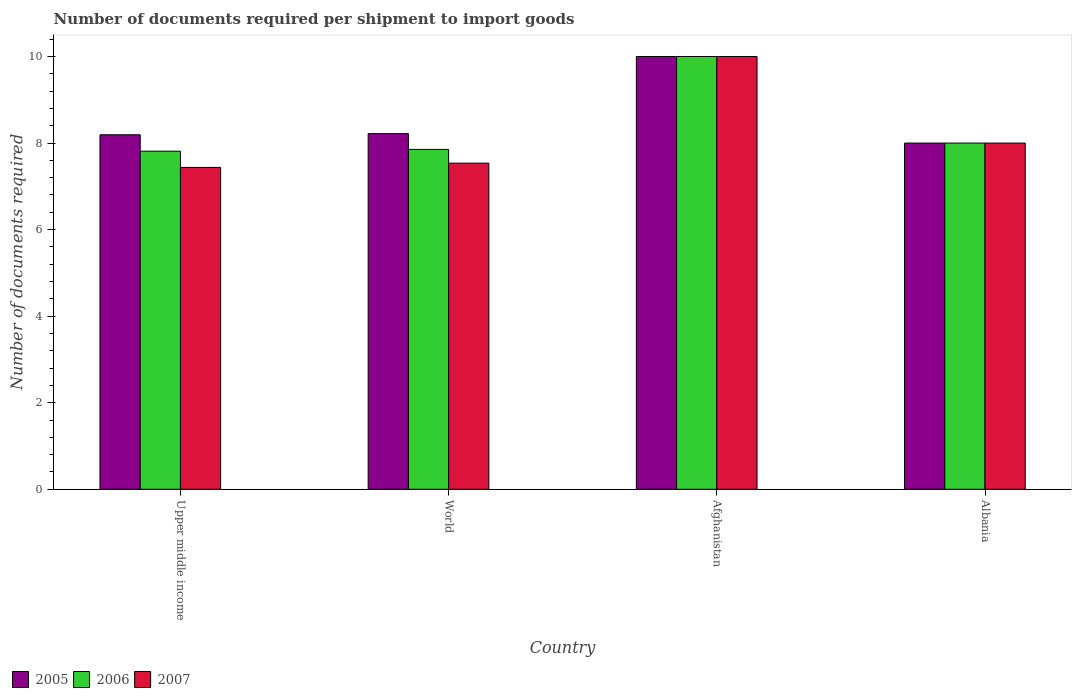How many groups of bars are there?
Your answer should be compact. 4. How many bars are there on the 4th tick from the left?
Make the answer very short. 3. What is the label of the 2nd group of bars from the left?
Your response must be concise. World. In how many cases, is the number of bars for a given country not equal to the number of legend labels?
Ensure brevity in your answer.  0. What is the number of documents required per shipment to import goods in 2007 in Afghanistan?
Give a very brief answer. 10. Across all countries, what is the maximum number of documents required per shipment to import goods in 2006?
Provide a succinct answer. 10. Across all countries, what is the minimum number of documents required per shipment to import goods in 2007?
Offer a very short reply. 7.44. In which country was the number of documents required per shipment to import goods in 2007 maximum?
Keep it short and to the point. Afghanistan. In which country was the number of documents required per shipment to import goods in 2006 minimum?
Provide a short and direct response. Upper middle income. What is the total number of documents required per shipment to import goods in 2007 in the graph?
Provide a succinct answer. 32.97. What is the difference between the number of documents required per shipment to import goods in 2006 in Afghanistan and that in World?
Keep it short and to the point. 2.15. What is the difference between the number of documents required per shipment to import goods in 2005 in World and the number of documents required per shipment to import goods in 2007 in Afghanistan?
Your response must be concise. -1.78. What is the average number of documents required per shipment to import goods in 2006 per country?
Keep it short and to the point. 8.42. What is the difference between the number of documents required per shipment to import goods of/in 2006 and number of documents required per shipment to import goods of/in 2005 in World?
Provide a succinct answer. -0.36. In how many countries, is the number of documents required per shipment to import goods in 2005 greater than 5.6?
Your answer should be compact. 4. Is the number of documents required per shipment to import goods in 2005 in Albania less than that in Upper middle income?
Provide a succinct answer. Yes. What is the difference between the highest and the second highest number of documents required per shipment to import goods in 2007?
Ensure brevity in your answer.  -2. In how many countries, is the number of documents required per shipment to import goods in 2006 greater than the average number of documents required per shipment to import goods in 2006 taken over all countries?
Ensure brevity in your answer.  1. Is the sum of the number of documents required per shipment to import goods in 2007 in Afghanistan and World greater than the maximum number of documents required per shipment to import goods in 2005 across all countries?
Provide a succinct answer. Yes. What does the 1st bar from the left in Afghanistan represents?
Offer a terse response. 2005. Is it the case that in every country, the sum of the number of documents required per shipment to import goods in 2005 and number of documents required per shipment to import goods in 2007 is greater than the number of documents required per shipment to import goods in 2006?
Ensure brevity in your answer.  Yes. How many bars are there?
Keep it short and to the point. 12. Are all the bars in the graph horizontal?
Give a very brief answer. No. What is the difference between two consecutive major ticks on the Y-axis?
Provide a short and direct response. 2. Are the values on the major ticks of Y-axis written in scientific E-notation?
Keep it short and to the point. No. Does the graph contain any zero values?
Offer a very short reply. No. Does the graph contain grids?
Your answer should be compact. No. How many legend labels are there?
Make the answer very short. 3. How are the legend labels stacked?
Ensure brevity in your answer.  Horizontal. What is the title of the graph?
Provide a succinct answer. Number of documents required per shipment to import goods. Does "2009" appear as one of the legend labels in the graph?
Provide a short and direct response. No. What is the label or title of the Y-axis?
Offer a very short reply. Number of documents required. What is the Number of documents required in 2005 in Upper middle income?
Your response must be concise. 8.19. What is the Number of documents required of 2006 in Upper middle income?
Make the answer very short. 7.81. What is the Number of documents required of 2007 in Upper middle income?
Give a very brief answer. 7.44. What is the Number of documents required of 2005 in World?
Ensure brevity in your answer.  8.22. What is the Number of documents required in 2006 in World?
Give a very brief answer. 7.85. What is the Number of documents required of 2007 in World?
Your answer should be compact. 7.54. What is the Number of documents required in 2005 in Afghanistan?
Keep it short and to the point. 10. What is the Number of documents required in 2007 in Afghanistan?
Your response must be concise. 10. What is the Number of documents required of 2007 in Albania?
Ensure brevity in your answer.  8. Across all countries, what is the maximum Number of documents required of 2006?
Your response must be concise. 10. Across all countries, what is the minimum Number of documents required in 2006?
Keep it short and to the point. 7.81. Across all countries, what is the minimum Number of documents required in 2007?
Your answer should be compact. 7.44. What is the total Number of documents required of 2005 in the graph?
Make the answer very short. 34.41. What is the total Number of documents required in 2006 in the graph?
Provide a short and direct response. 33.67. What is the total Number of documents required in 2007 in the graph?
Provide a short and direct response. 32.97. What is the difference between the Number of documents required of 2005 in Upper middle income and that in World?
Your response must be concise. -0.03. What is the difference between the Number of documents required of 2006 in Upper middle income and that in World?
Offer a very short reply. -0.04. What is the difference between the Number of documents required in 2007 in Upper middle income and that in World?
Give a very brief answer. -0.1. What is the difference between the Number of documents required in 2005 in Upper middle income and that in Afghanistan?
Offer a terse response. -1.81. What is the difference between the Number of documents required of 2006 in Upper middle income and that in Afghanistan?
Provide a short and direct response. -2.19. What is the difference between the Number of documents required in 2007 in Upper middle income and that in Afghanistan?
Your response must be concise. -2.56. What is the difference between the Number of documents required in 2005 in Upper middle income and that in Albania?
Your answer should be compact. 0.19. What is the difference between the Number of documents required of 2006 in Upper middle income and that in Albania?
Ensure brevity in your answer.  -0.19. What is the difference between the Number of documents required in 2007 in Upper middle income and that in Albania?
Make the answer very short. -0.56. What is the difference between the Number of documents required in 2005 in World and that in Afghanistan?
Ensure brevity in your answer.  -1.78. What is the difference between the Number of documents required of 2006 in World and that in Afghanistan?
Offer a very short reply. -2.15. What is the difference between the Number of documents required of 2007 in World and that in Afghanistan?
Provide a short and direct response. -2.46. What is the difference between the Number of documents required in 2005 in World and that in Albania?
Offer a very short reply. 0.22. What is the difference between the Number of documents required of 2006 in World and that in Albania?
Make the answer very short. -0.15. What is the difference between the Number of documents required in 2007 in World and that in Albania?
Offer a very short reply. -0.46. What is the difference between the Number of documents required in 2005 in Afghanistan and that in Albania?
Your response must be concise. 2. What is the difference between the Number of documents required in 2006 in Afghanistan and that in Albania?
Your response must be concise. 2. What is the difference between the Number of documents required in 2007 in Afghanistan and that in Albania?
Provide a succinct answer. 2. What is the difference between the Number of documents required of 2005 in Upper middle income and the Number of documents required of 2006 in World?
Your response must be concise. 0.34. What is the difference between the Number of documents required in 2005 in Upper middle income and the Number of documents required in 2007 in World?
Ensure brevity in your answer.  0.66. What is the difference between the Number of documents required in 2006 in Upper middle income and the Number of documents required in 2007 in World?
Make the answer very short. 0.28. What is the difference between the Number of documents required of 2005 in Upper middle income and the Number of documents required of 2006 in Afghanistan?
Ensure brevity in your answer.  -1.81. What is the difference between the Number of documents required in 2005 in Upper middle income and the Number of documents required in 2007 in Afghanistan?
Provide a succinct answer. -1.81. What is the difference between the Number of documents required of 2006 in Upper middle income and the Number of documents required of 2007 in Afghanistan?
Offer a very short reply. -2.19. What is the difference between the Number of documents required of 2005 in Upper middle income and the Number of documents required of 2006 in Albania?
Offer a very short reply. 0.19. What is the difference between the Number of documents required in 2005 in Upper middle income and the Number of documents required in 2007 in Albania?
Provide a short and direct response. 0.19. What is the difference between the Number of documents required in 2006 in Upper middle income and the Number of documents required in 2007 in Albania?
Offer a terse response. -0.19. What is the difference between the Number of documents required in 2005 in World and the Number of documents required in 2006 in Afghanistan?
Your response must be concise. -1.78. What is the difference between the Number of documents required in 2005 in World and the Number of documents required in 2007 in Afghanistan?
Provide a short and direct response. -1.78. What is the difference between the Number of documents required of 2006 in World and the Number of documents required of 2007 in Afghanistan?
Make the answer very short. -2.15. What is the difference between the Number of documents required of 2005 in World and the Number of documents required of 2006 in Albania?
Your answer should be compact. 0.22. What is the difference between the Number of documents required in 2005 in World and the Number of documents required in 2007 in Albania?
Make the answer very short. 0.22. What is the difference between the Number of documents required of 2006 in World and the Number of documents required of 2007 in Albania?
Your answer should be very brief. -0.15. What is the difference between the Number of documents required of 2005 in Afghanistan and the Number of documents required of 2006 in Albania?
Offer a terse response. 2. What is the average Number of documents required in 2005 per country?
Provide a short and direct response. 8.6. What is the average Number of documents required in 2006 per country?
Make the answer very short. 8.42. What is the average Number of documents required in 2007 per country?
Provide a succinct answer. 8.24. What is the difference between the Number of documents required in 2005 and Number of documents required in 2006 in Upper middle income?
Make the answer very short. 0.38. What is the difference between the Number of documents required in 2005 and Number of documents required in 2007 in Upper middle income?
Provide a succinct answer. 0.75. What is the difference between the Number of documents required of 2005 and Number of documents required of 2006 in World?
Keep it short and to the point. 0.36. What is the difference between the Number of documents required in 2005 and Number of documents required in 2007 in World?
Make the answer very short. 0.68. What is the difference between the Number of documents required in 2006 and Number of documents required in 2007 in World?
Provide a succinct answer. 0.32. What is the difference between the Number of documents required in 2005 and Number of documents required in 2007 in Afghanistan?
Make the answer very short. 0. What is the difference between the Number of documents required of 2006 and Number of documents required of 2007 in Afghanistan?
Your response must be concise. 0. What is the ratio of the Number of documents required in 2007 in Upper middle income to that in World?
Provide a short and direct response. 0.99. What is the ratio of the Number of documents required in 2005 in Upper middle income to that in Afghanistan?
Make the answer very short. 0.82. What is the ratio of the Number of documents required of 2006 in Upper middle income to that in Afghanistan?
Your response must be concise. 0.78. What is the ratio of the Number of documents required in 2007 in Upper middle income to that in Afghanistan?
Offer a very short reply. 0.74. What is the ratio of the Number of documents required of 2005 in Upper middle income to that in Albania?
Ensure brevity in your answer.  1.02. What is the ratio of the Number of documents required of 2006 in Upper middle income to that in Albania?
Your answer should be very brief. 0.98. What is the ratio of the Number of documents required of 2007 in Upper middle income to that in Albania?
Ensure brevity in your answer.  0.93. What is the ratio of the Number of documents required in 2005 in World to that in Afghanistan?
Provide a short and direct response. 0.82. What is the ratio of the Number of documents required in 2006 in World to that in Afghanistan?
Offer a very short reply. 0.79. What is the ratio of the Number of documents required of 2007 in World to that in Afghanistan?
Give a very brief answer. 0.75. What is the ratio of the Number of documents required in 2005 in World to that in Albania?
Your response must be concise. 1.03. What is the ratio of the Number of documents required in 2006 in World to that in Albania?
Your response must be concise. 0.98. What is the ratio of the Number of documents required in 2007 in World to that in Albania?
Provide a short and direct response. 0.94. What is the ratio of the Number of documents required of 2005 in Afghanistan to that in Albania?
Offer a terse response. 1.25. What is the ratio of the Number of documents required in 2006 in Afghanistan to that in Albania?
Offer a very short reply. 1.25. What is the ratio of the Number of documents required of 2007 in Afghanistan to that in Albania?
Provide a short and direct response. 1.25. What is the difference between the highest and the second highest Number of documents required of 2005?
Keep it short and to the point. 1.78. What is the difference between the highest and the second highest Number of documents required in 2006?
Offer a terse response. 2. What is the difference between the highest and the lowest Number of documents required of 2006?
Provide a short and direct response. 2.19. What is the difference between the highest and the lowest Number of documents required in 2007?
Offer a terse response. 2.56. 